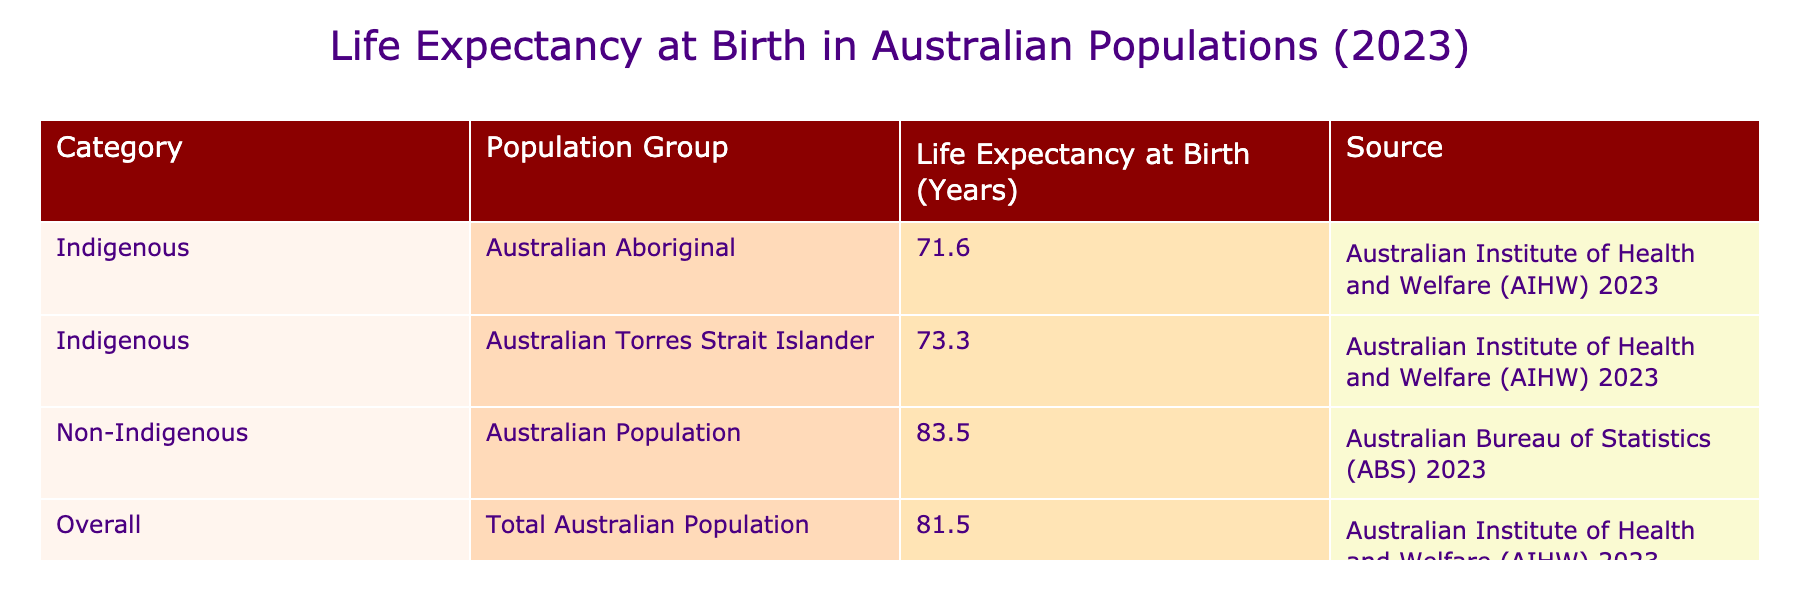What is the life expectancy at birth for Australian Aboriginal people? According to the table, the life expectancy at birth for Australian Aboriginal people, which is listed under the Indigenous population group, is 71.6 years.
Answer: 71.6 years What is the life expectancy at birth for Australian Torres Strait Islander people? The life expectancy at birth for Australian Torres Strait Islander people is given in the table as 73.3 years.
Answer: 73.3 years How much longer do non-Indigenous Australians live compared to Australian Aboriginal people? Non-Indigenous Australians have a life expectancy of 83.5 years and Australian Aboriginal people have a life expectancy of 71.6 years. The difference is 83.5 - 71.6 = 11.9 years.
Answer: 11.9 years Is the life expectancy at birth of the total Australian population greater than that of Australian Torres Strait Islander people? The table shows that the total Australian population has a life expectancy at birth of 81.5 years, while Australian Torres Strait Islander people have a life expectancy of 73.3 years. Since 81.5 is greater than 73.3, the statement is true.
Answer: Yes What is the average life expectancy at birth for both Indigenous population groups? The life expectancy for Australian Aboriginal people is 71.6 years and for Australian Torres Strait Islander people is 73.3 years. To find the average, we sum these values: 71.6 + 73.3 = 144.9 years and divide by 2, resulting in 144.9 / 2 = 72.45 years.
Answer: 72.45 years How does the life expectancy of Australian Torres Strait Islander people compare to the overall Australian population? Australian Torres Strait Islander people have a life expectancy at birth of 73.3 years, and the total Australian population has a life expectancy of 81.5 years. Since 73.3 is less than 81.5, the life expectancy for Torres Strait Islander people is lower than that of the overall population.
Answer: Lower What is the total life expectancy at birth for the Indigenous population group when combining both sub-groups? The life expectancy for Australian Aboriginal people is 71.6 years and for Torres Strait Islander people is 73.3 years. Therefore, to get the total, we can sum these values: 71.6 + 73.3 = 144.9 years. This represents the combined life expectancy of both groups, not an average.
Answer: 144.9 years Is it true that the life expectancy at birth is shorter for Indigenous Australians than for non-Indigenous Australians? The life expectancy for the Indigenous population group (71.6 and 73.3 years) is less than that of non-Indigenous Australians (83.5 years). Therefore, the statement is true.
Answer: Yes What is the difference in life expectancy between the overall Australian population and Australian Aboriginal people? The overall Australian population has a life expectancy of 81.5 years while Australian Aboriginal people have 71.6 years. The difference is calculated as 81.5 - 71.6 = 9.9 years.
Answer: 9.9 years 